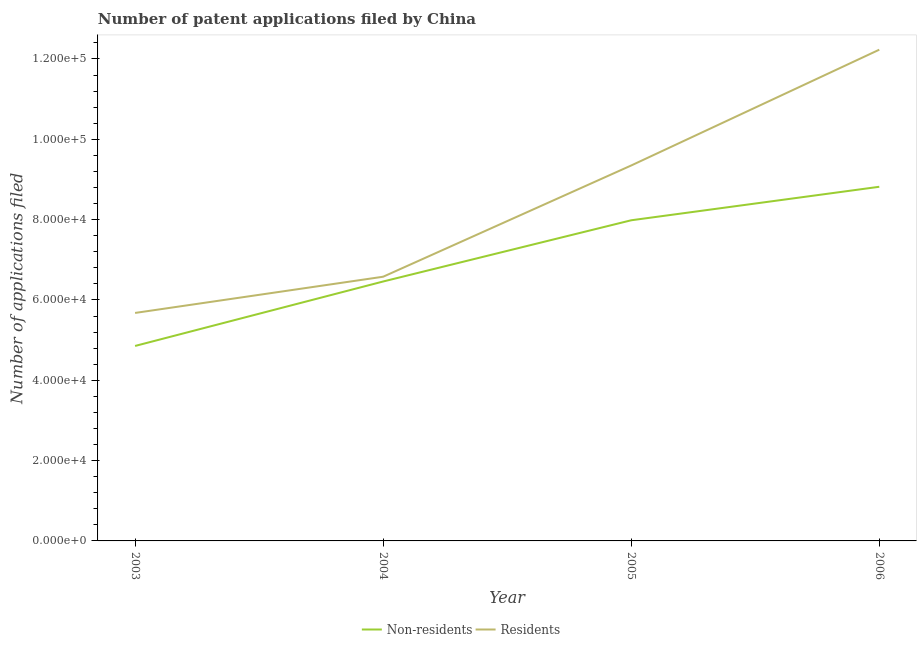Is the number of lines equal to the number of legend labels?
Give a very brief answer. Yes. What is the number of patent applications by non residents in 2003?
Provide a short and direct response. 4.85e+04. Across all years, what is the maximum number of patent applications by residents?
Provide a short and direct response. 1.22e+05. Across all years, what is the minimum number of patent applications by residents?
Your answer should be very brief. 5.68e+04. In which year was the number of patent applications by residents maximum?
Your answer should be compact. 2006. What is the total number of patent applications by non residents in the graph?
Your answer should be very brief. 2.81e+05. What is the difference between the number of patent applications by non residents in 2003 and that in 2004?
Your answer should be compact. -1.60e+04. What is the difference between the number of patent applications by residents in 2004 and the number of patent applications by non residents in 2006?
Your answer should be compact. -2.24e+04. What is the average number of patent applications by residents per year?
Keep it short and to the point. 8.46e+04. In the year 2006, what is the difference between the number of patent applications by non residents and number of patent applications by residents?
Your answer should be compact. -3.41e+04. What is the ratio of the number of patent applications by residents in 2003 to that in 2006?
Keep it short and to the point. 0.46. Is the number of patent applications by non residents in 2003 less than that in 2004?
Ensure brevity in your answer.  Yes. Is the difference between the number of patent applications by non residents in 2004 and 2005 greater than the difference between the number of patent applications by residents in 2004 and 2005?
Offer a terse response. Yes. What is the difference between the highest and the second highest number of patent applications by non residents?
Offer a terse response. 8341. What is the difference between the highest and the lowest number of patent applications by residents?
Keep it short and to the point. 6.55e+04. Is the number of patent applications by non residents strictly greater than the number of patent applications by residents over the years?
Keep it short and to the point. No. How many lines are there?
Ensure brevity in your answer.  2. How many years are there in the graph?
Offer a terse response. 4. What is the difference between two consecutive major ticks on the Y-axis?
Make the answer very short. 2.00e+04. Are the values on the major ticks of Y-axis written in scientific E-notation?
Your response must be concise. Yes. Where does the legend appear in the graph?
Ensure brevity in your answer.  Bottom center. How many legend labels are there?
Provide a succinct answer. 2. How are the legend labels stacked?
Keep it short and to the point. Horizontal. What is the title of the graph?
Ensure brevity in your answer.  Number of patent applications filed by China. What is the label or title of the Y-axis?
Offer a terse response. Number of applications filed. What is the Number of applications filed of Non-residents in 2003?
Provide a succinct answer. 4.85e+04. What is the Number of applications filed of Residents in 2003?
Offer a very short reply. 5.68e+04. What is the Number of applications filed of Non-residents in 2004?
Your answer should be very brief. 6.46e+04. What is the Number of applications filed in Residents in 2004?
Ensure brevity in your answer.  6.58e+04. What is the Number of applications filed of Non-residents in 2005?
Offer a terse response. 7.98e+04. What is the Number of applications filed of Residents in 2005?
Ensure brevity in your answer.  9.35e+04. What is the Number of applications filed of Non-residents in 2006?
Your answer should be compact. 8.82e+04. What is the Number of applications filed in Residents in 2006?
Ensure brevity in your answer.  1.22e+05. Across all years, what is the maximum Number of applications filed in Non-residents?
Your response must be concise. 8.82e+04. Across all years, what is the maximum Number of applications filed in Residents?
Your response must be concise. 1.22e+05. Across all years, what is the minimum Number of applications filed of Non-residents?
Your answer should be compact. 4.85e+04. Across all years, what is the minimum Number of applications filed of Residents?
Ensure brevity in your answer.  5.68e+04. What is the total Number of applications filed of Non-residents in the graph?
Provide a short and direct response. 2.81e+05. What is the total Number of applications filed in Residents in the graph?
Keep it short and to the point. 3.38e+05. What is the difference between the Number of applications filed in Non-residents in 2003 and that in 2004?
Your answer should be very brief. -1.60e+04. What is the difference between the Number of applications filed of Residents in 2003 and that in 2004?
Ensure brevity in your answer.  -9017. What is the difference between the Number of applications filed in Non-residents in 2003 and that in 2005?
Keep it short and to the point. -3.13e+04. What is the difference between the Number of applications filed in Residents in 2003 and that in 2005?
Offer a terse response. -3.67e+04. What is the difference between the Number of applications filed of Non-residents in 2003 and that in 2006?
Offer a terse response. -3.96e+04. What is the difference between the Number of applications filed of Residents in 2003 and that in 2006?
Give a very brief answer. -6.55e+04. What is the difference between the Number of applications filed of Non-residents in 2004 and that in 2005?
Your answer should be very brief. -1.52e+04. What is the difference between the Number of applications filed of Residents in 2004 and that in 2005?
Provide a succinct answer. -2.77e+04. What is the difference between the Number of applications filed of Non-residents in 2004 and that in 2006?
Offer a very short reply. -2.36e+04. What is the difference between the Number of applications filed of Residents in 2004 and that in 2006?
Provide a succinct answer. -5.65e+04. What is the difference between the Number of applications filed of Non-residents in 2005 and that in 2006?
Your answer should be very brief. -8341. What is the difference between the Number of applications filed in Residents in 2005 and that in 2006?
Give a very brief answer. -2.88e+04. What is the difference between the Number of applications filed of Non-residents in 2003 and the Number of applications filed of Residents in 2004?
Ensure brevity in your answer.  -1.72e+04. What is the difference between the Number of applications filed of Non-residents in 2003 and the Number of applications filed of Residents in 2005?
Make the answer very short. -4.49e+04. What is the difference between the Number of applications filed of Non-residents in 2003 and the Number of applications filed of Residents in 2006?
Make the answer very short. -7.38e+04. What is the difference between the Number of applications filed in Non-residents in 2004 and the Number of applications filed in Residents in 2005?
Provide a short and direct response. -2.89e+04. What is the difference between the Number of applications filed of Non-residents in 2004 and the Number of applications filed of Residents in 2006?
Your response must be concise. -5.77e+04. What is the difference between the Number of applications filed of Non-residents in 2005 and the Number of applications filed of Residents in 2006?
Offer a terse response. -4.25e+04. What is the average Number of applications filed of Non-residents per year?
Provide a succinct answer. 7.03e+04. What is the average Number of applications filed of Residents per year?
Offer a very short reply. 8.46e+04. In the year 2003, what is the difference between the Number of applications filed in Non-residents and Number of applications filed in Residents?
Provide a short and direct response. -8221. In the year 2004, what is the difference between the Number of applications filed of Non-residents and Number of applications filed of Residents?
Give a very brief answer. -1188. In the year 2005, what is the difference between the Number of applications filed of Non-residents and Number of applications filed of Residents?
Offer a very short reply. -1.36e+04. In the year 2006, what is the difference between the Number of applications filed of Non-residents and Number of applications filed of Residents?
Your response must be concise. -3.41e+04. What is the ratio of the Number of applications filed in Non-residents in 2003 to that in 2004?
Provide a succinct answer. 0.75. What is the ratio of the Number of applications filed of Residents in 2003 to that in 2004?
Your answer should be very brief. 0.86. What is the ratio of the Number of applications filed in Non-residents in 2003 to that in 2005?
Provide a short and direct response. 0.61. What is the ratio of the Number of applications filed of Residents in 2003 to that in 2005?
Offer a very short reply. 0.61. What is the ratio of the Number of applications filed of Non-residents in 2003 to that in 2006?
Offer a terse response. 0.55. What is the ratio of the Number of applications filed of Residents in 2003 to that in 2006?
Your answer should be compact. 0.46. What is the ratio of the Number of applications filed in Non-residents in 2004 to that in 2005?
Provide a short and direct response. 0.81. What is the ratio of the Number of applications filed in Residents in 2004 to that in 2005?
Provide a short and direct response. 0.7. What is the ratio of the Number of applications filed in Non-residents in 2004 to that in 2006?
Keep it short and to the point. 0.73. What is the ratio of the Number of applications filed in Residents in 2004 to that in 2006?
Provide a short and direct response. 0.54. What is the ratio of the Number of applications filed of Non-residents in 2005 to that in 2006?
Offer a terse response. 0.91. What is the ratio of the Number of applications filed in Residents in 2005 to that in 2006?
Keep it short and to the point. 0.76. What is the difference between the highest and the second highest Number of applications filed of Non-residents?
Ensure brevity in your answer.  8341. What is the difference between the highest and the second highest Number of applications filed of Residents?
Give a very brief answer. 2.88e+04. What is the difference between the highest and the lowest Number of applications filed in Non-residents?
Ensure brevity in your answer.  3.96e+04. What is the difference between the highest and the lowest Number of applications filed of Residents?
Keep it short and to the point. 6.55e+04. 